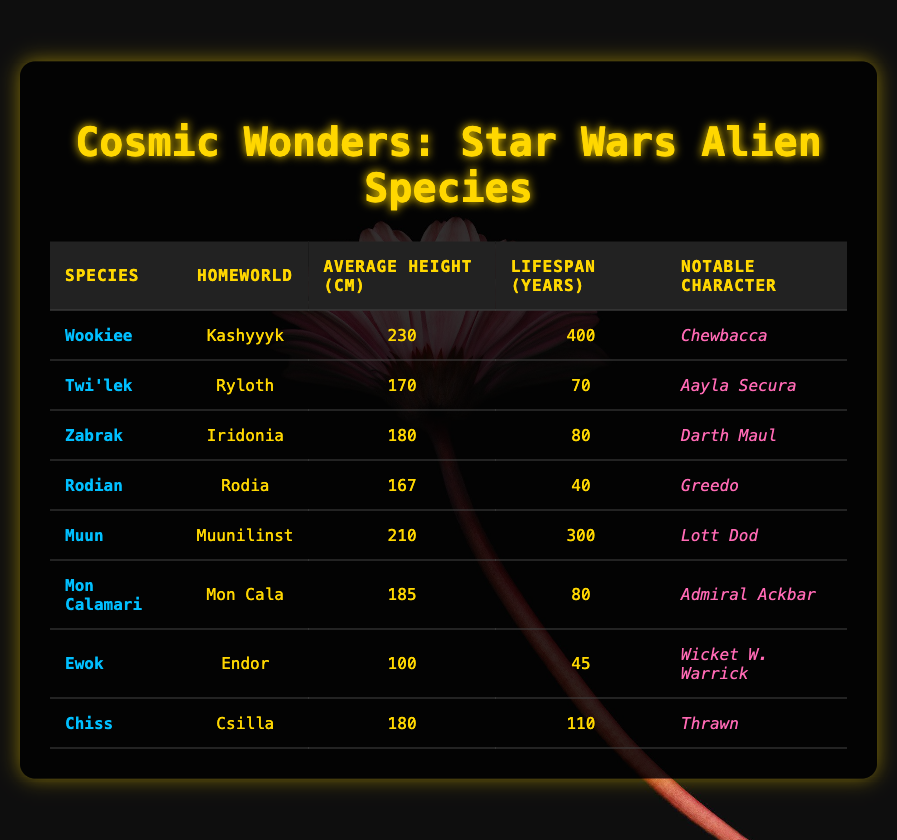What is the average height of a Wookiee? The table states that the average height of a Wookiee is 230 cm.
Answer: 230 cm Which species has the shortest average height? By examining the average heights, the Ewok has the shortest average height at 100 cm.
Answer: Ewok Is it true that all species listed have a lifespan of more than 40 years? The only species with a lifespan of 40 years is the Rodian. Therefore, not all species have a lifespan of more than 40 years.
Answer: No What is the total average height of the Mon Calamari and the Zabrak? The average height of the Mon Calamari is 185 cm and the Zabrak is 180 cm. Summing these gives: 185 + 180 = 365 cm.
Answer: 365 cm Which species has the longest lifespan, and how long is it? The Wookiee has the longest lifespan listed at 400 years.
Answer: Wookiee, 400 years If we list all species with a lifespan of over 100 years, how many would there be? The only species with a lifespan over 100 years is the Wookiee at 400 years and the Muun at 300 years, totaling 2 species.
Answer: 2 What is the average lifespan of all the species listed? To calculate this, add all the lifespans: 400 + 70 + 80 + 40 + 300 + 80 + 45 + 110 = 1125. There are 8 species, so 1125 / 8 = 140.625, which rounds up to 141 years.
Answer: 141 years How much taller is a Muun compared to a Rodian? The Muun's average height is 210 cm and the Rodian's is 167 cm. Calculating the difference: 210 - 167 = 43 cm.
Answer: 43 cm Which species is associated with the notable character Thrawn? In the table, the Chiss is associated with the notable character Thrawn.
Answer: Chiss 